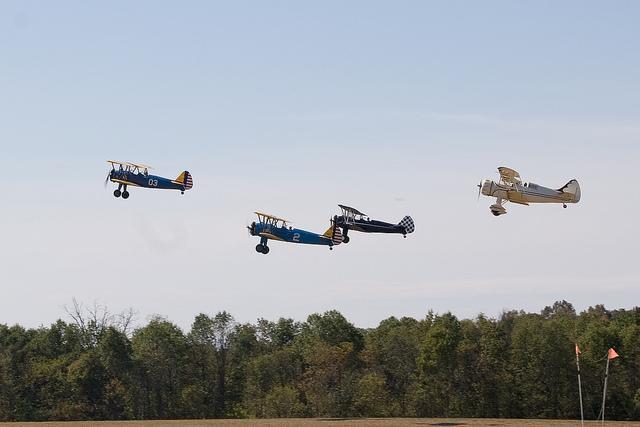What type of activities are happening here?
Choose the correct response, then elucidate: 'Answer: answer
Rationale: rationale.'
Options: Winter, electronic, aquatic, aviation. Answer: aviation.
Rationale: Several planes are in the air flying in formation. 